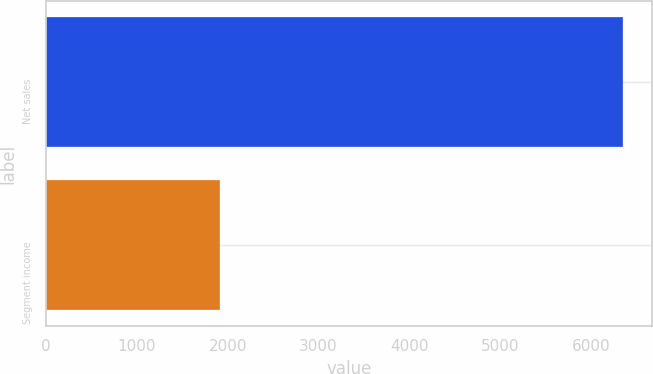Convert chart. <chart><loc_0><loc_0><loc_500><loc_500><bar_chart><fcel>Net sales<fcel>Segment income<nl><fcel>6352.7<fcel>1916.2<nl></chart> 